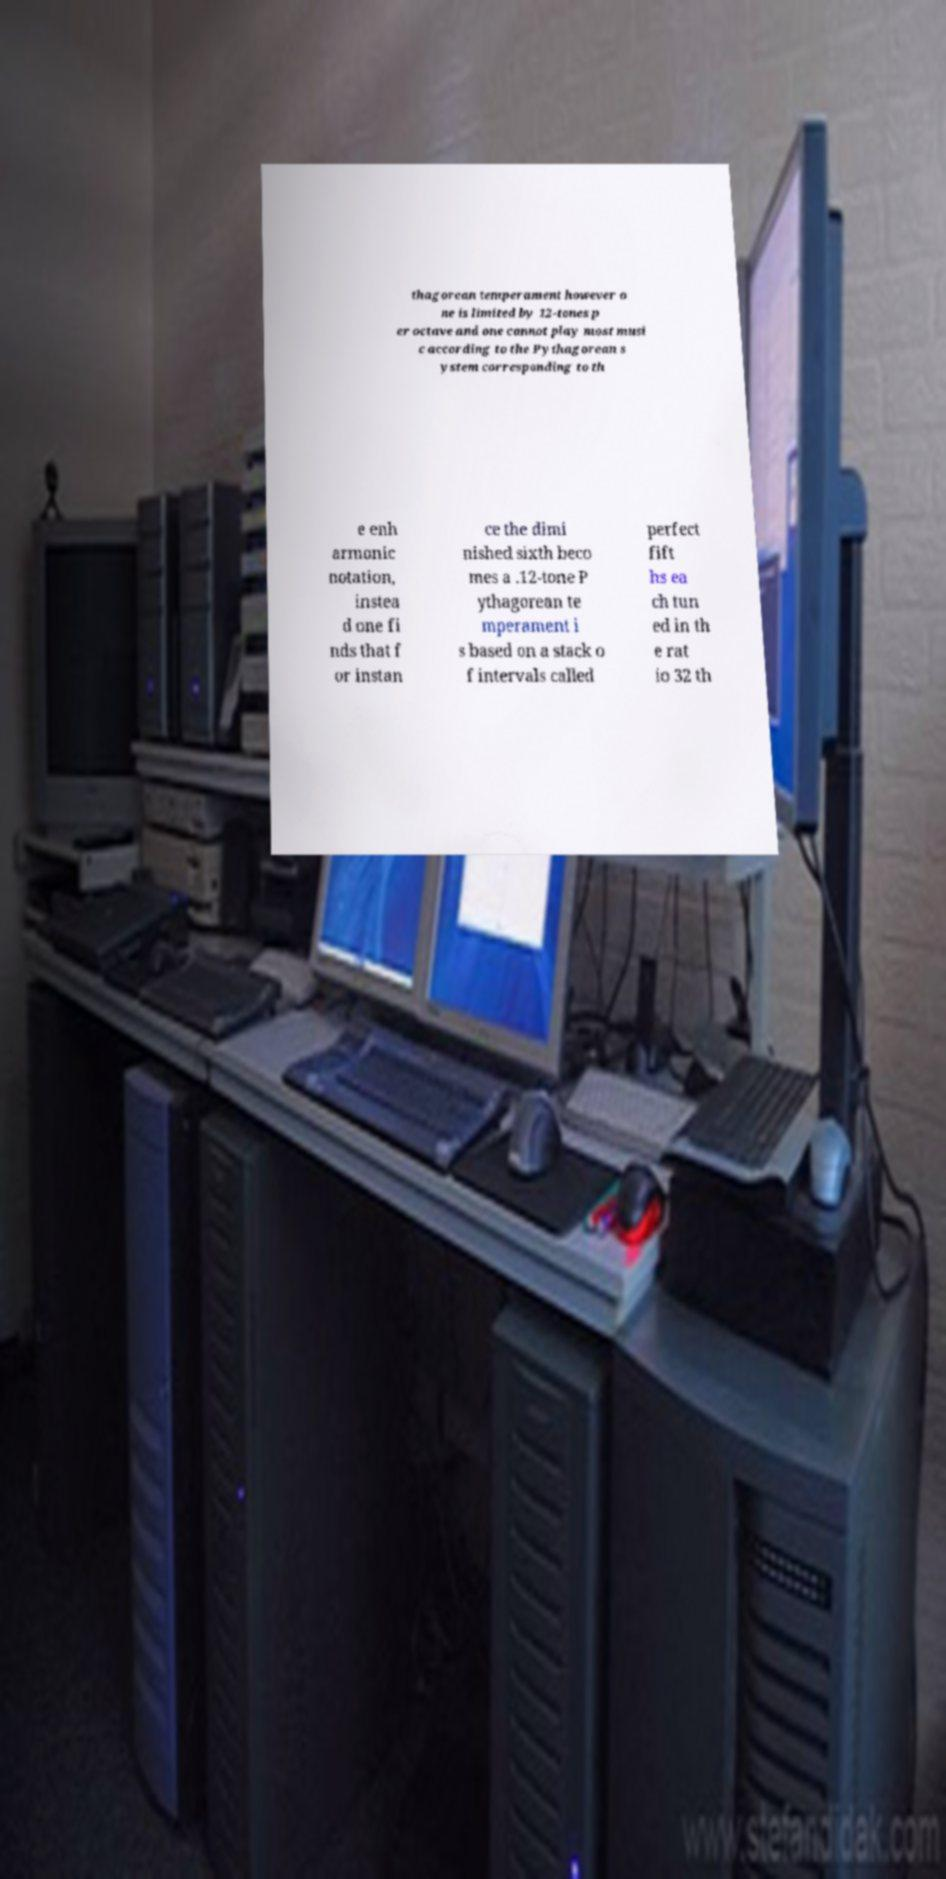Can you accurately transcribe the text from the provided image for me? thagorean temperament however o ne is limited by 12-tones p er octave and one cannot play most musi c according to the Pythagorean s ystem corresponding to th e enh armonic notation, instea d one fi nds that f or instan ce the dimi nished sixth beco mes a .12-tone P ythagorean te mperament i s based on a stack o f intervals called perfect fift hs ea ch tun ed in th e rat io 32 th 